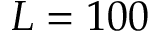<formula> <loc_0><loc_0><loc_500><loc_500>L = 1 0 0</formula> 